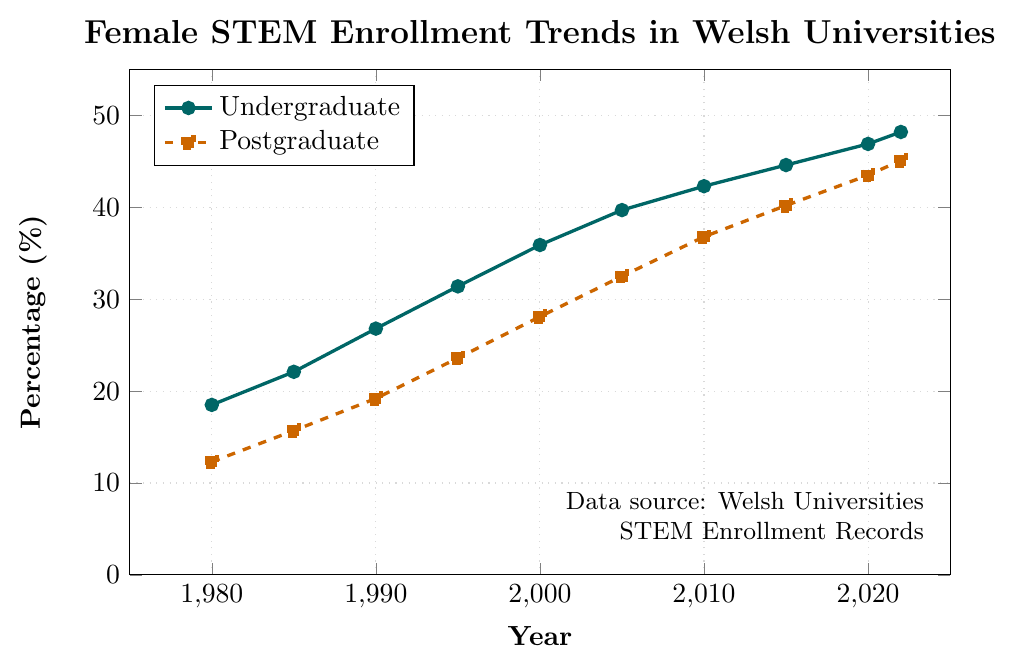What was the percentage increase in undergraduate female STEM enrollment from 1980 to 1990? First, find the percentage in 1980 which is 18.5%, and in 1990 which is 26.8%. Then, subtract the 1980 percentage from the 1990 percentage: 26.8% - 18.5% = 8.3%.
Answer: 8.3% How much higher was the postgraduate female STEM enrollment percentage in 2022 compared to 2000? First, find the percentage in 2022 which is 45.1%, and in 2000 which is 28.1%. Then, subtract the 2000 percentage from the 2022 percentage: 45.1% - 28.1% = 17%.
Answer: 17% By how many percentage points did undergraduate female STEM enrollment increase between 2005 and 2015? First, locate the percentages: in 2005 it is 39.7% and in 2015 it is 44.6%. Then, subtract the 2005 percentage from the 2015 percentage: 44.6% - 39.7% = 4.9%.
Answer: 4.9% Which year showed the highest postgraduate female STEM enrollment percentage, and what was that percentage? Find the highest data point for postgraduate enrollment, which is in 2022 with a percentage of 45.1%.
Answer: 2022, 45.1% Compare the trends of undergraduate and postgraduate female STEM enrollment from 1980 to 2022. Which level shows a steeper overall increase? The undergraduate enrollment increased from 18.5% to 48.2% (29.7% increase) while the postgraduate enrollment increased from 12.3% to 45.1% (32.8% increase). Although the absolute increase in postgraduate enrollment is smaller, the postgraduate level shows a larger percentage increase relative to its initial value, indicating a steeper overall increase.
Answer: Postgraduate In which 5-year interval did postgraduate female STEM enrollment see the largest percentage increase? Calculate the percentage increases for each 5-year interval between 1980 and 2020. The largest increase occurred from 1980-1985 (15.7% - 12.3% = 3.4%).
Answer: 1980-1985 What was the cumulative percentage increase in undergraduate female STEM enrollment from 1980 to 2022? First, get the percentages for 1980 (18.5%) and 2022 (48.2%). Subtract the former from the latter: 48.2% - 18.5% = 29.7%.
Answer: 29.7% What are the colors representing undergraduate and postgraduate enrollments in the chart? The plot uses teal for undergraduate and orange for postgraduate enrollment lines.
Answer: Teal and Orange What is the difference between undergraduate and postgraduate female STEM enrollment percentages in 2010? The undergraduate percentage in 2010 is 42.3% and the postgraduate percentage is 36.8%. Subtract the postgraduate value from the undergraduate value: 42.3% - 36.8% = 5.5%.
Answer: 5.5% Which enrollment level achieved more than a 40% female STEM enrollment first and in which year? Locate the first year in each plot line where the percentage exceeds 40%. For undergraduates, it is 2010, and for postgraduates, it is 2015. Undergraduate achieved it first.
Answer: Undergraduate, 2010 